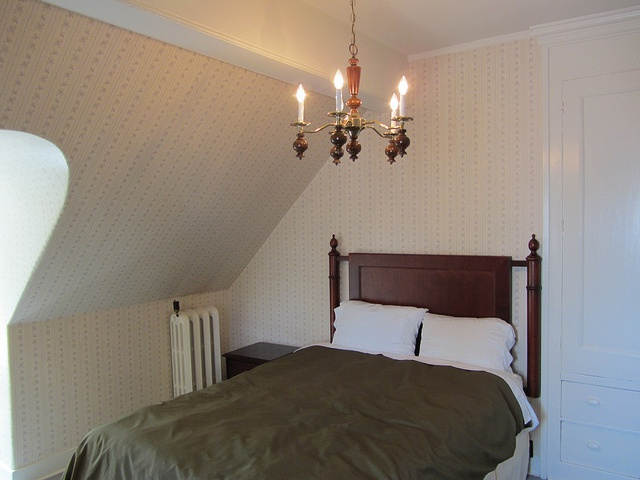Describe the objects in this image and their specific colors. I can see a bed in gray, black, and darkgray tones in this image. 